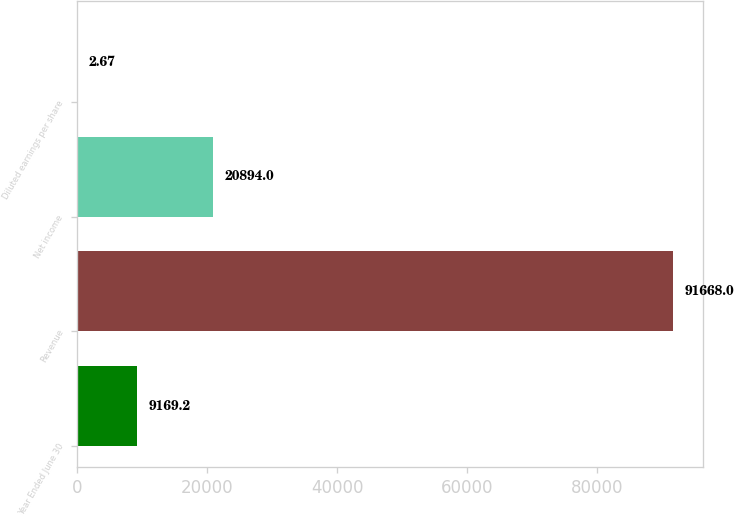Convert chart. <chart><loc_0><loc_0><loc_500><loc_500><bar_chart><fcel>Year Ended June 30<fcel>Revenue<fcel>Net income<fcel>Diluted earnings per share<nl><fcel>9169.2<fcel>91668<fcel>20894<fcel>2.67<nl></chart> 